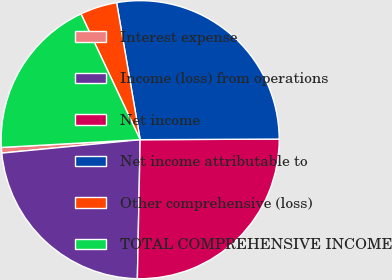Convert chart to OTSL. <chart><loc_0><loc_0><loc_500><loc_500><pie_chart><fcel>Interest expense<fcel>Income (loss) from operations<fcel>Net income<fcel>Net income attributable to<fcel>Other comprehensive (loss)<fcel>TOTAL COMPREHENSIVE INCOME<nl><fcel>0.65%<fcel>23.14%<fcel>25.39%<fcel>27.64%<fcel>4.29%<fcel>18.89%<nl></chart> 